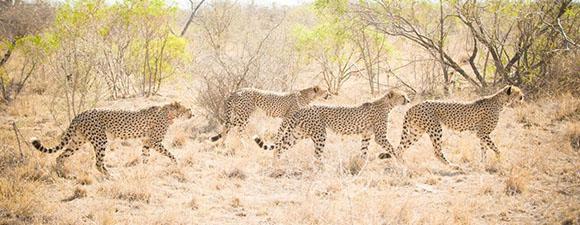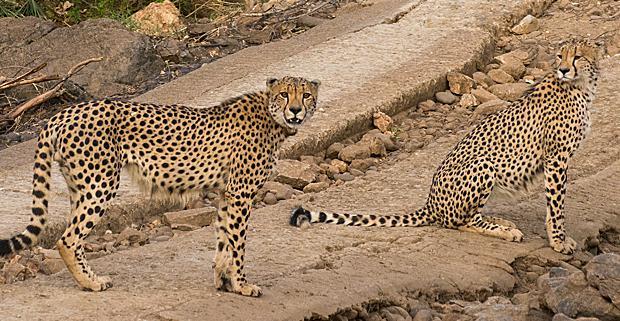The first image is the image on the left, the second image is the image on the right. Given the left and right images, does the statement "One image contains exactly one cheetah, which faces the camera, and the other image contains cheetahs with overlapping bodies." hold true? Answer yes or no. No. The first image is the image on the left, the second image is the image on the right. Analyze the images presented: Is the assertion "In at least one image there is a single leopard whose facing is left forward." valid? Answer yes or no. No. 